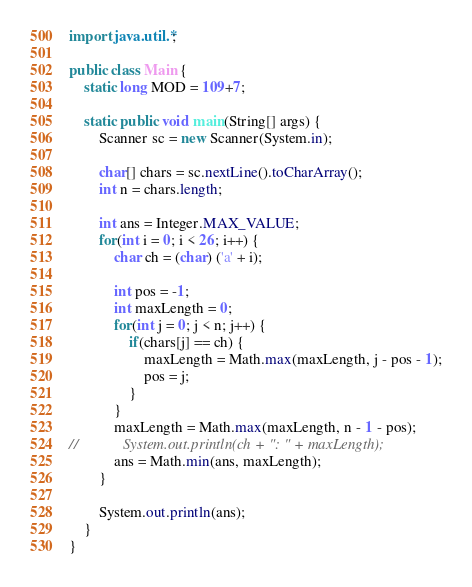<code> <loc_0><loc_0><loc_500><loc_500><_Java_>
import java.util.*;

public class Main {
    static long MOD = 109+7;

    static public void main(String[] args) {
        Scanner sc = new Scanner(System.in);

        char[] chars = sc.nextLine().toCharArray();
        int n = chars.length;

        int ans = Integer.MAX_VALUE;
        for(int i = 0; i < 26; i++) {
            char ch = (char) ('a' + i);

            int pos = -1;
            int maxLength = 0;
            for(int j = 0; j < n; j++) {
                if(chars[j] == ch) {
                    maxLength = Math.max(maxLength, j - pos - 1);
                    pos = j;
                }
            }
            maxLength = Math.max(maxLength, n - 1 - pos);
//            System.out.println(ch + ": " + maxLength);
            ans = Math.min(ans, maxLength);
        }

        System.out.println(ans);
    }
}</code> 